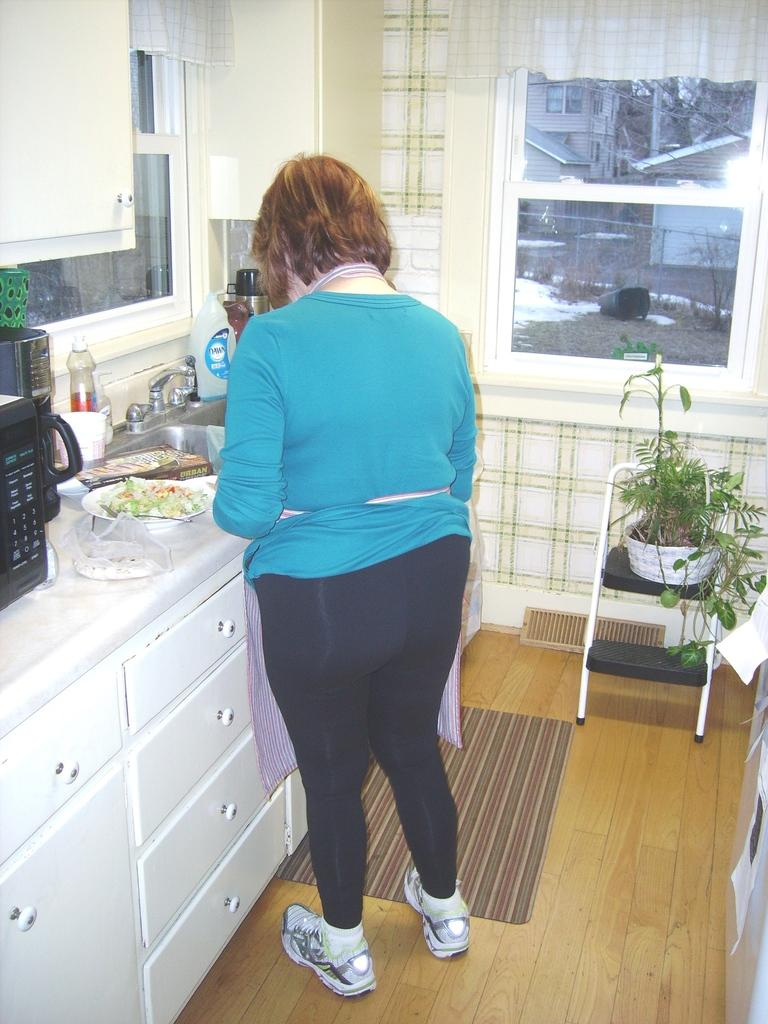Who is the main subject in the image? There is a woman in the image. Where is the woman positioned in the image? The woman is standing in the center of the image. What is the woman doing in the image? The woman is working in a kitchen. What object can be seen on a chair in the image? There is a clay pot on a chair. On which side of the image is the chair located? The chair is on the right side of the image. What type of crown is the woman wearing in the image? There is no crown present in the image; the woman is working in a kitchen. 